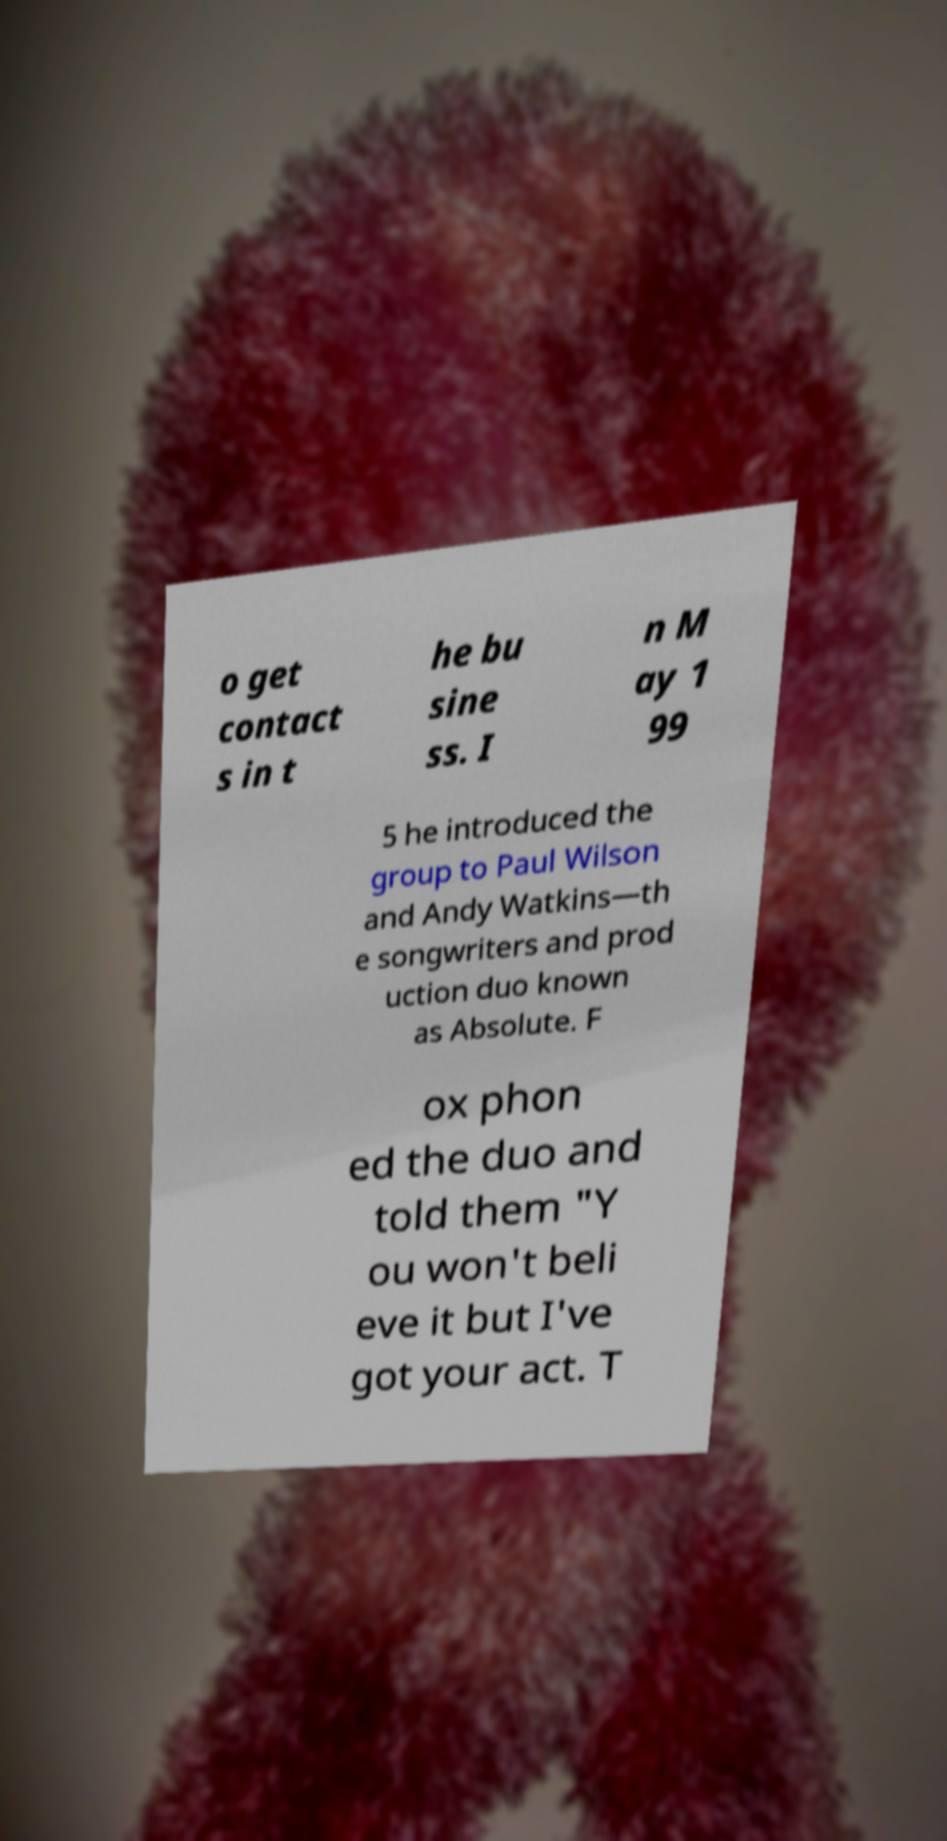What messages or text are displayed in this image? I need them in a readable, typed format. o get contact s in t he bu sine ss. I n M ay 1 99 5 he introduced the group to Paul Wilson and Andy Watkins—th e songwriters and prod uction duo known as Absolute. F ox phon ed the duo and told them "Y ou won't beli eve it but I've got your act. T 